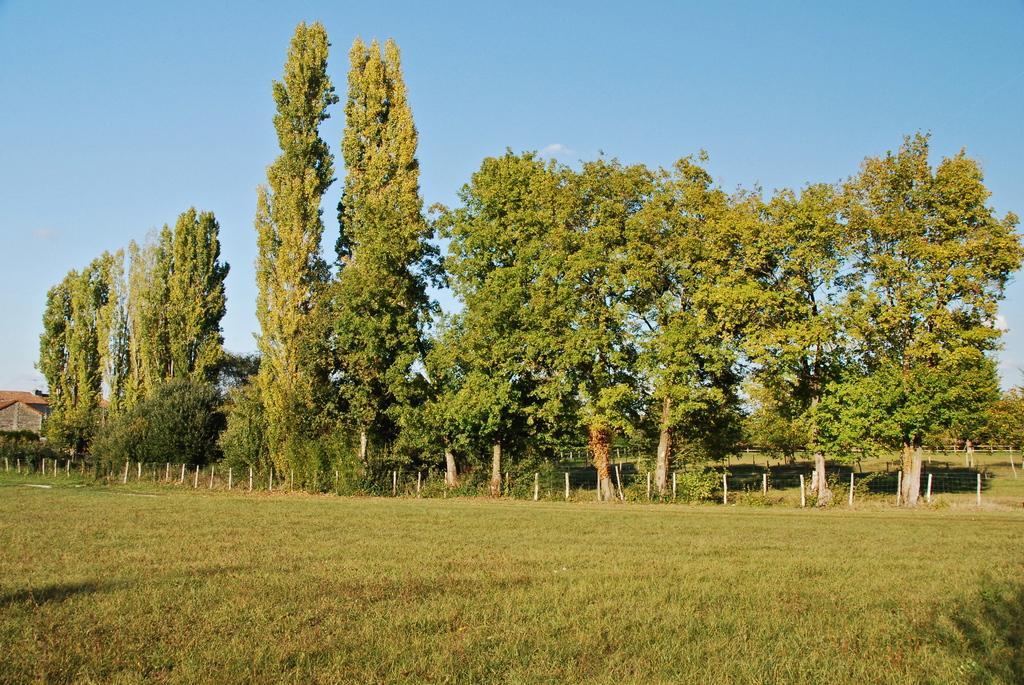What type of surface is visible in the image? There is a grass surface in the image. What can be seen in the background of the image? There is fencing with a wire and poles, trees, a house, and the sky visible in the background. Can you describe the argument between the rabbits in the image? There are no rabbits present in the image, so there cannot be an argument between them. 